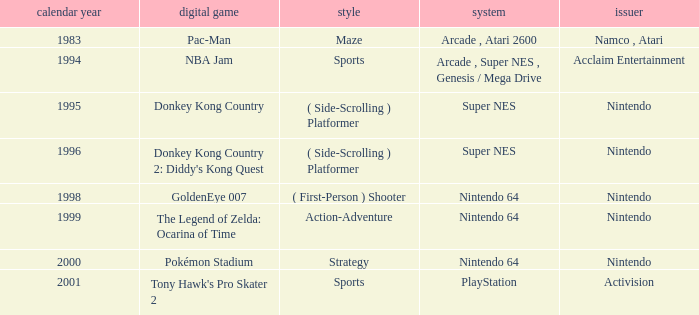Which Genre has a Game of tony hawk's pro skater 2? Sports. 